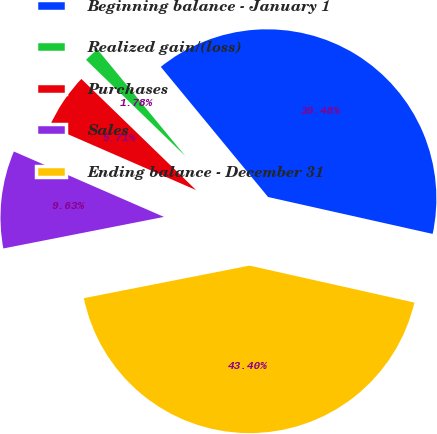Convert chart. <chart><loc_0><loc_0><loc_500><loc_500><pie_chart><fcel>Beginning balance - January 1<fcel>Realized gain/(loss)<fcel>Purchases<fcel>Sales<fcel>Ending balance - December 31<nl><fcel>39.48%<fcel>1.78%<fcel>5.71%<fcel>9.63%<fcel>43.4%<nl></chart> 